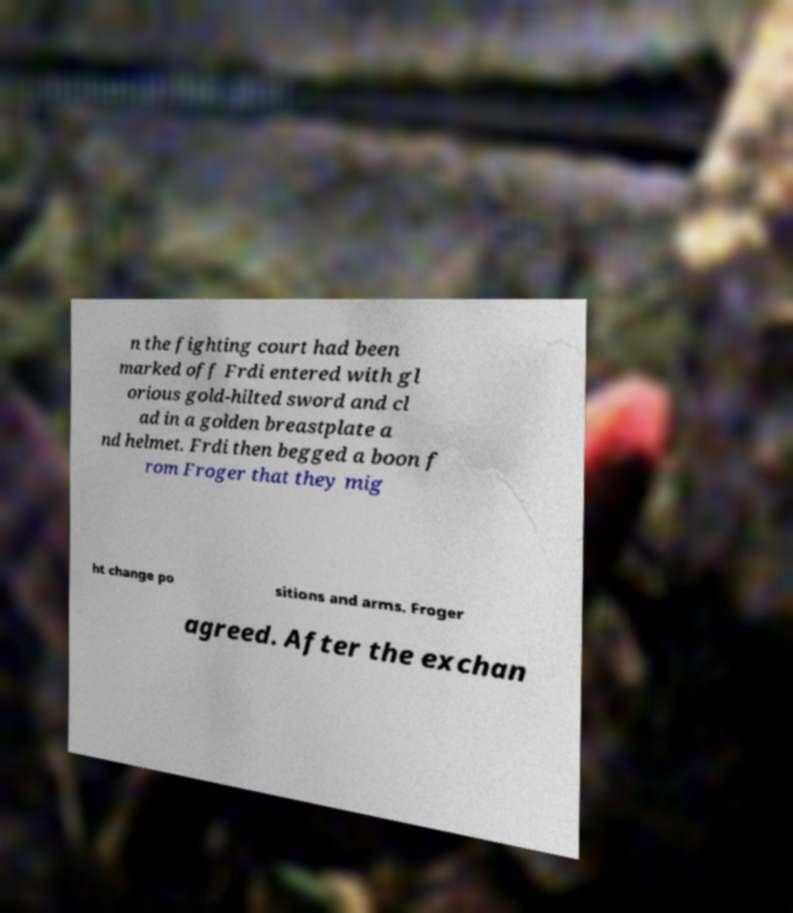Can you accurately transcribe the text from the provided image for me? n the fighting court had been marked off Frdi entered with gl orious gold-hilted sword and cl ad in a golden breastplate a nd helmet. Frdi then begged a boon f rom Froger that they mig ht change po sitions and arms. Froger agreed. After the exchan 